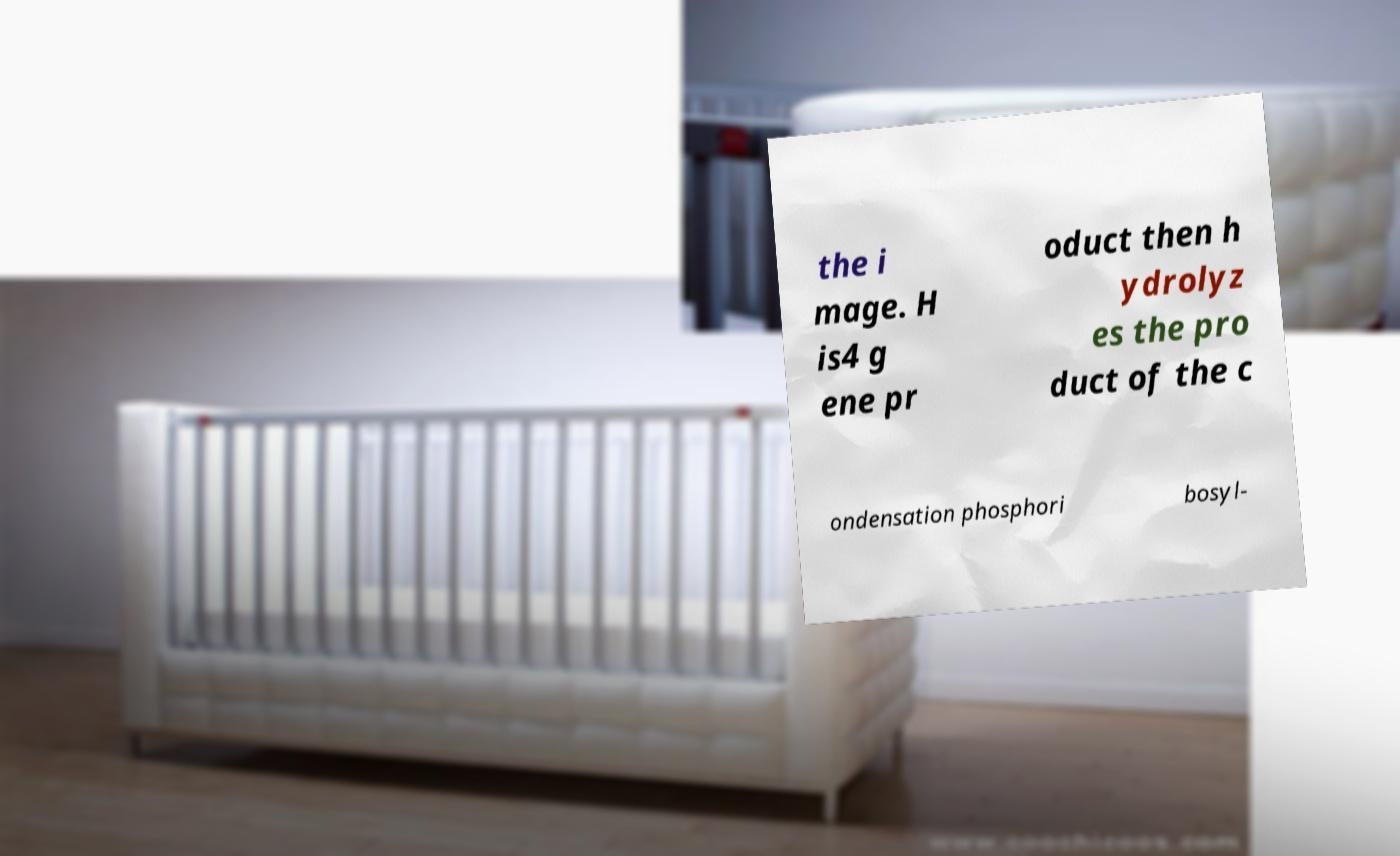What messages or text are displayed in this image? I need them in a readable, typed format. the i mage. H is4 g ene pr oduct then h ydrolyz es the pro duct of the c ondensation phosphori bosyl- 